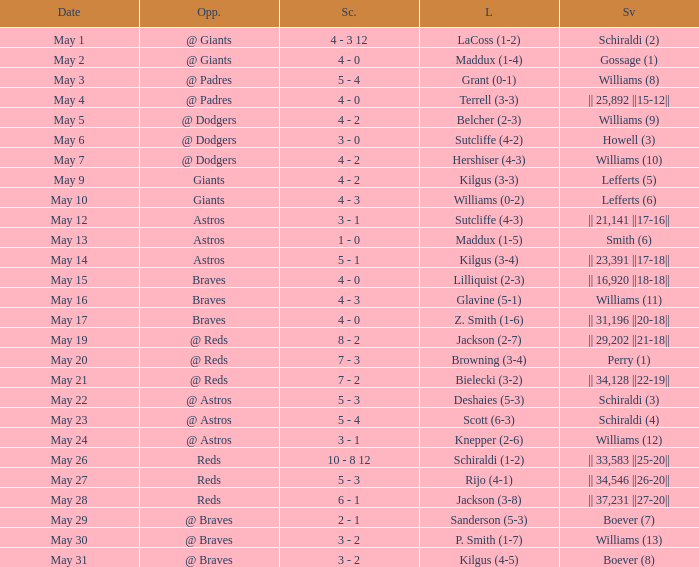Name the loss with save of || 23,391 ||17-18||? Kilgus (3-4). 